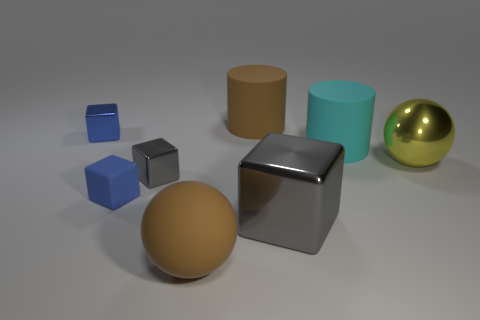Subtract all blue cylinders. How many blue blocks are left? 2 Subtract all large gray shiny blocks. How many blocks are left? 3 Subtract 2 blocks. How many blocks are left? 2 Add 2 big green matte cylinders. How many objects exist? 10 Subtract all red blocks. Subtract all cyan cylinders. How many blocks are left? 4 Subtract all cylinders. How many objects are left? 6 Subtract 0 red blocks. How many objects are left? 8 Subtract all brown balls. Subtract all brown cylinders. How many objects are left? 6 Add 3 shiny spheres. How many shiny spheres are left? 4 Add 2 yellow metallic spheres. How many yellow metallic spheres exist? 3 